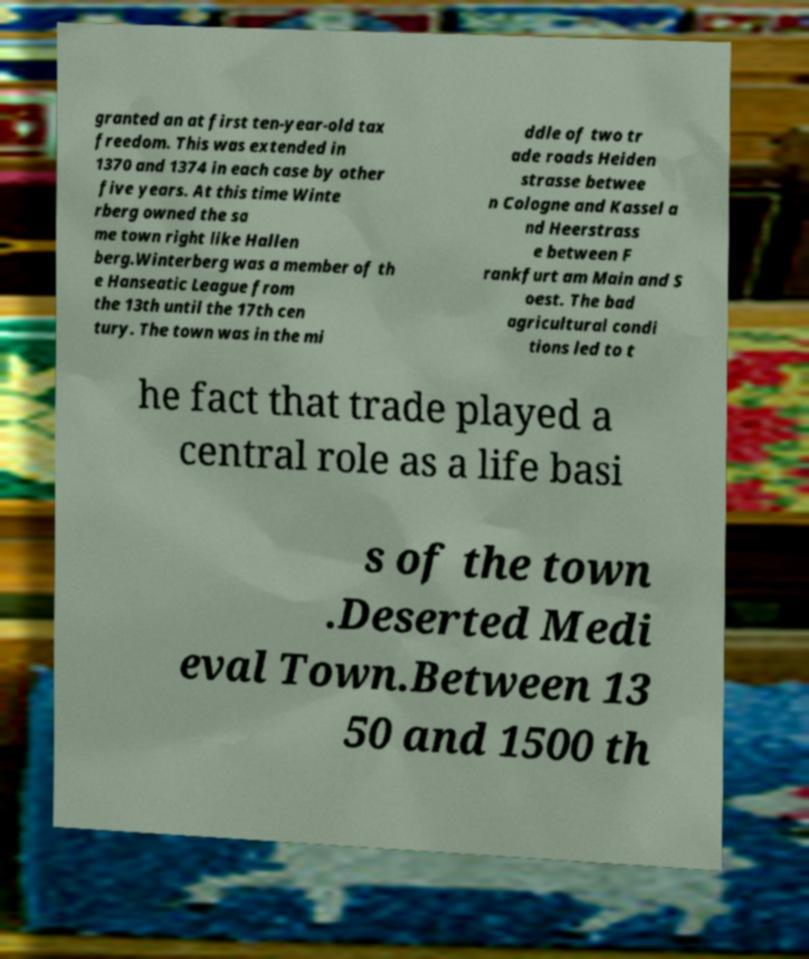What messages or text are displayed in this image? I need them in a readable, typed format. granted an at first ten-year-old tax freedom. This was extended in 1370 and 1374 in each case by other five years. At this time Winte rberg owned the sa me town right like Hallen berg.Winterberg was a member of th e Hanseatic League from the 13th until the 17th cen tury. The town was in the mi ddle of two tr ade roads Heiden strasse betwee n Cologne and Kassel a nd Heerstrass e between F rankfurt am Main and S oest. The bad agricultural condi tions led to t he fact that trade played a central role as a life basi s of the town .Deserted Medi eval Town.Between 13 50 and 1500 th 